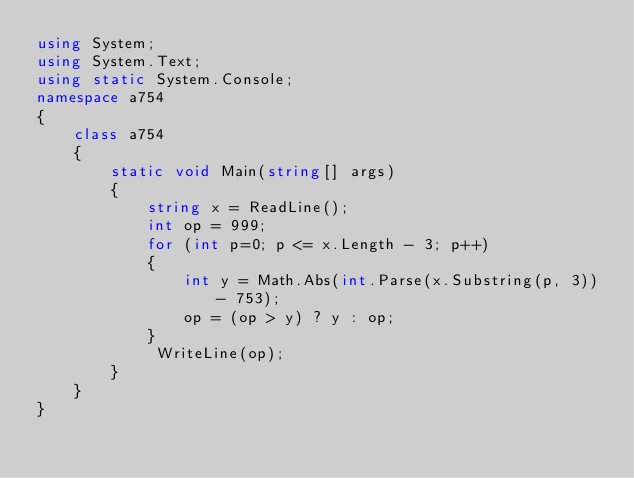<code> <loc_0><loc_0><loc_500><loc_500><_C#_>using System;
using System.Text;
using static System.Console;
namespace a754
{
    class a754
    {
        static void Main(string[] args)
        {
            string x = ReadLine();
            int op = 999;
            for (int p=0; p <= x.Length - 3; p++)
            {
                int y = Math.Abs(int.Parse(x.Substring(p, 3)) - 753);
                op = (op > y) ? y : op;
            }            
             WriteLine(op);
        }
    }
}</code> 